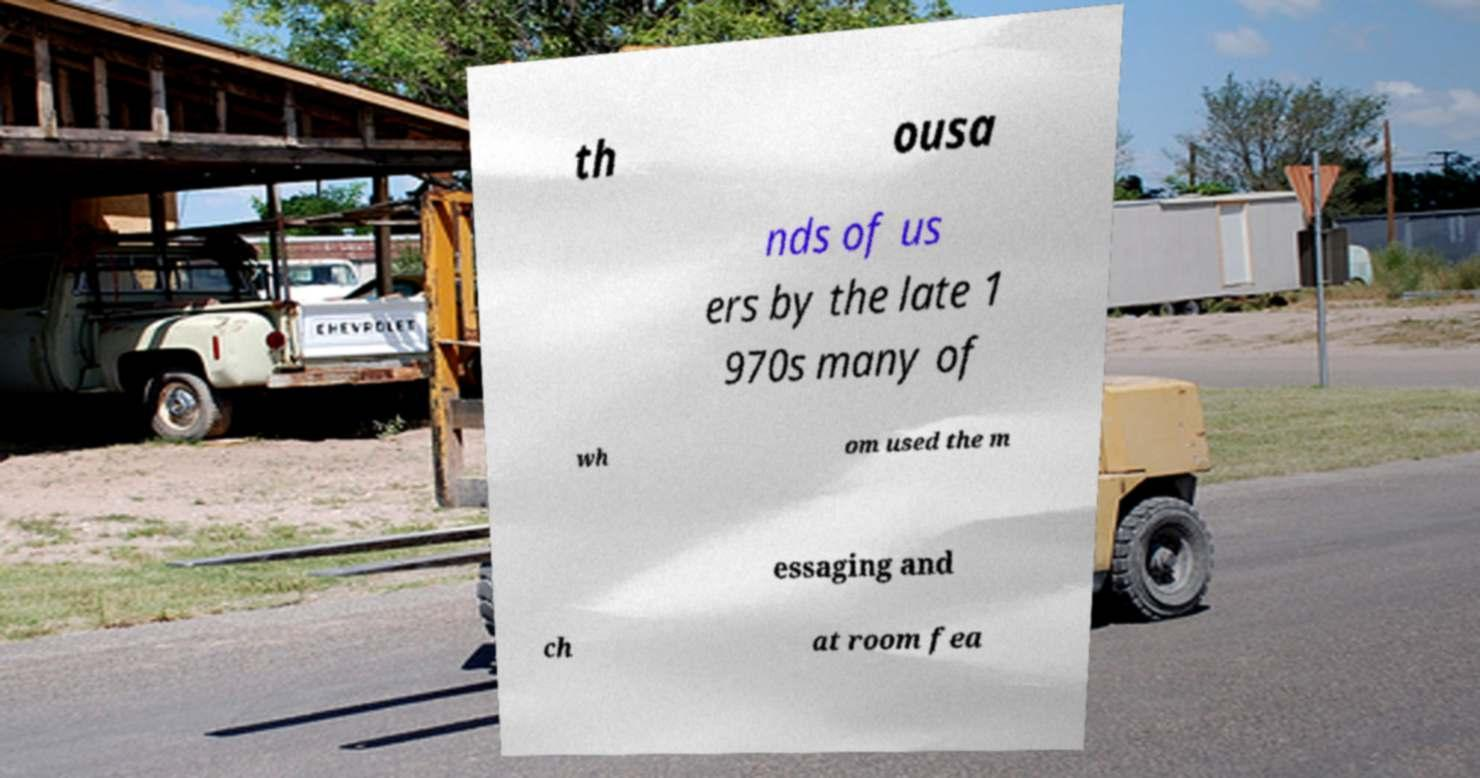Can you read and provide the text displayed in the image?This photo seems to have some interesting text. Can you extract and type it out for me? th ousa nds of us ers by the late 1 970s many of wh om used the m essaging and ch at room fea 